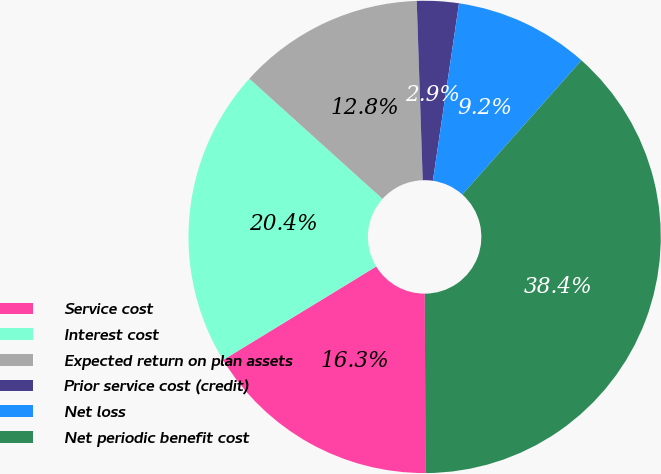Convert chart to OTSL. <chart><loc_0><loc_0><loc_500><loc_500><pie_chart><fcel>Service cost<fcel>Interest cost<fcel>Expected return on plan assets<fcel>Prior service cost (credit)<fcel>Net loss<fcel>Net periodic benefit cost<nl><fcel>16.33%<fcel>20.41%<fcel>12.78%<fcel>2.86%<fcel>9.23%<fcel>38.39%<nl></chart> 